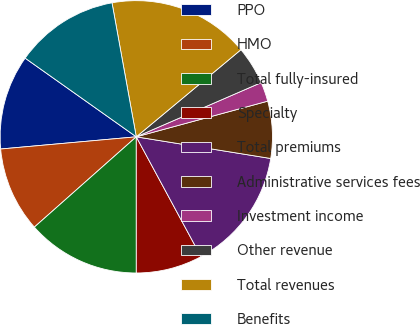Convert chart to OTSL. <chart><loc_0><loc_0><loc_500><loc_500><pie_chart><fcel>PPO<fcel>HMO<fcel>Total fully-insured<fcel>Specialty<fcel>Total premiums<fcel>Administrative services fees<fcel>Investment income<fcel>Other revenue<fcel>Total revenues<fcel>Benefits<nl><fcel>11.23%<fcel>10.11%<fcel>13.46%<fcel>7.88%<fcel>14.57%<fcel>6.76%<fcel>2.3%<fcel>4.53%<fcel>16.8%<fcel>12.34%<nl></chart> 